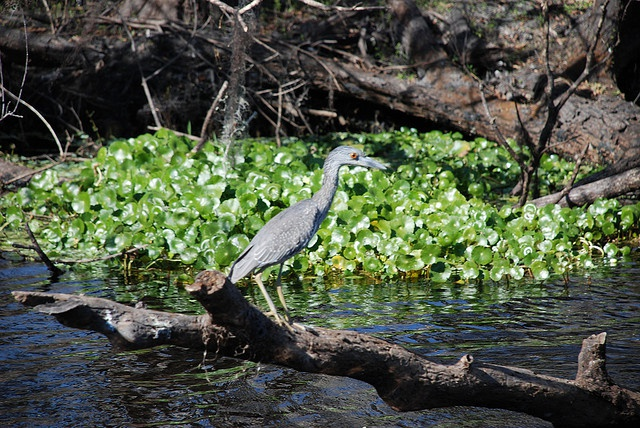Describe the objects in this image and their specific colors. I can see a bird in black, darkgray, and lightgray tones in this image. 